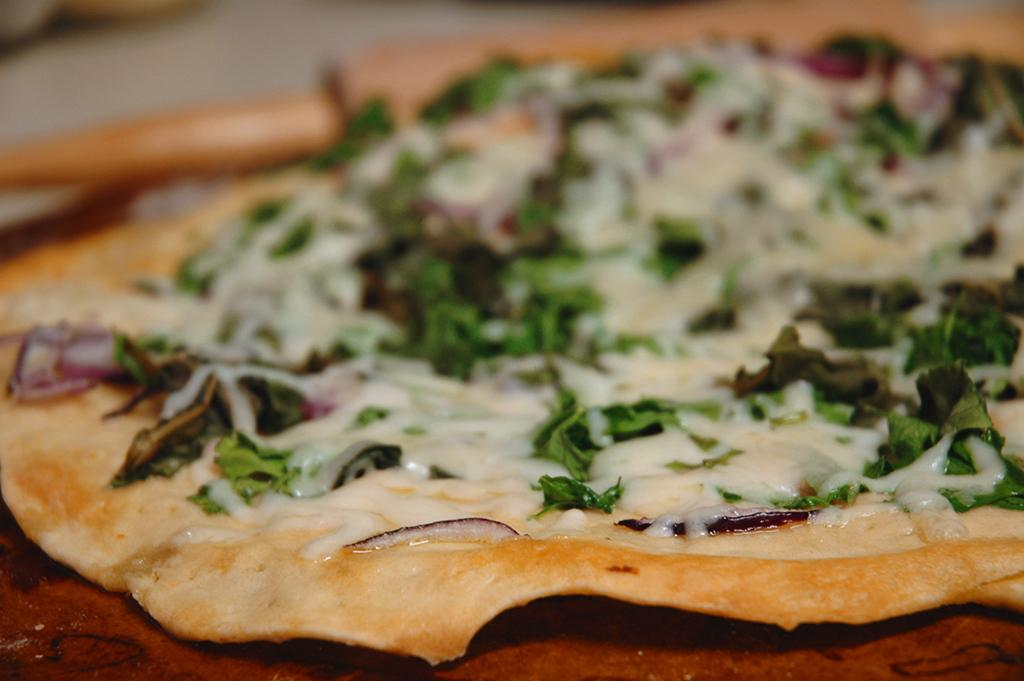What is the main subject of the image? The main subject of the image is food. What can be observed about the surface on which the food is placed? The food is on a brown color surface. What colors are present in the food? The food has colors of brown, white, and green. What type of horn can be seen in the image? There is no horn present in the image; it features food on a brown color surface. Can you tell me how many parents are visible in the image? There are no parents present in the image; it features food on a brown color surface. 